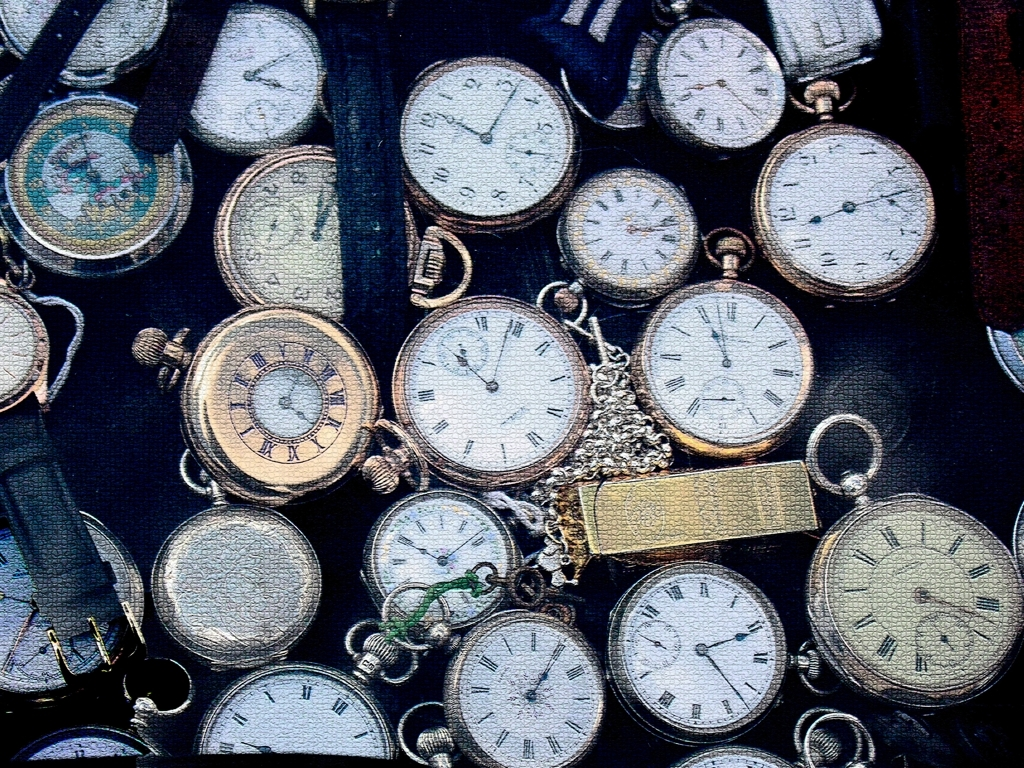Are there any unique features or details in the watches that stand out? Upon closer inspection, one can observe that some watches have distinct engravings on their cases, which could indicate craftsmanship or mark them as special editions. Another unique feature is the diversity in watch hands styles; some are sleek and minimalist, while others are intricate, which could reflect the time period or maker's brand. Finally, the differences in the watch faces, from simple white backgrounds to more artistic ones, suggest varied levels of artistry and function. 